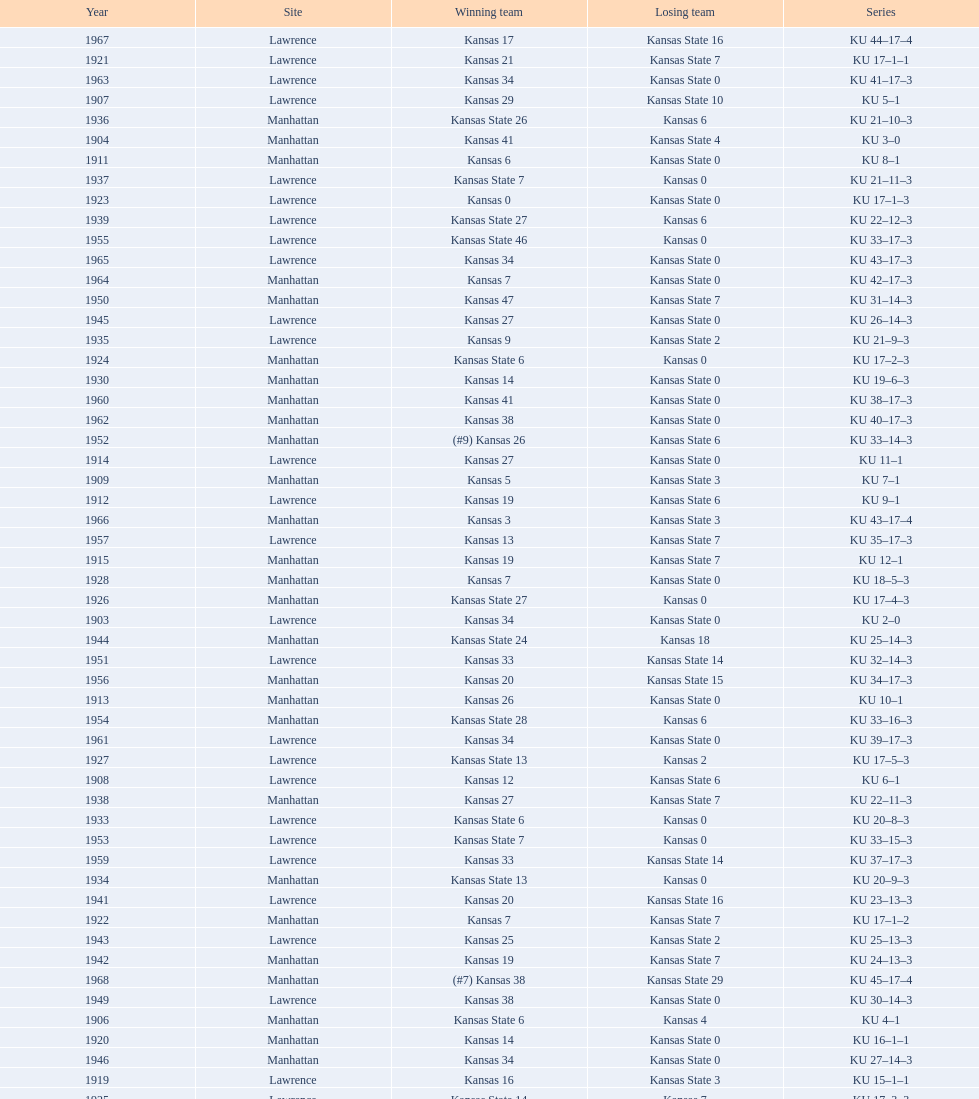Who had the most wins in the 1950's: kansas or kansas state? Kansas. 